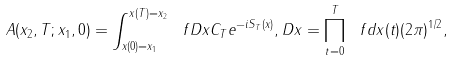Convert formula to latex. <formula><loc_0><loc_0><loc_500><loc_500>A ( x _ { 2 } , T ; x _ { 1 } , 0 ) = \int ^ { x ( T ) = x _ { 2 } } _ { x ( 0 ) = x _ { 1 } } \ f { D x } { C _ { T } } e ^ { - i S _ { T } ( x ) } , D x = \prod _ { t = 0 } ^ { T } \ f { d x ( t ) } { ( 2 \pi ) ^ { 1 / 2 } } ,</formula> 